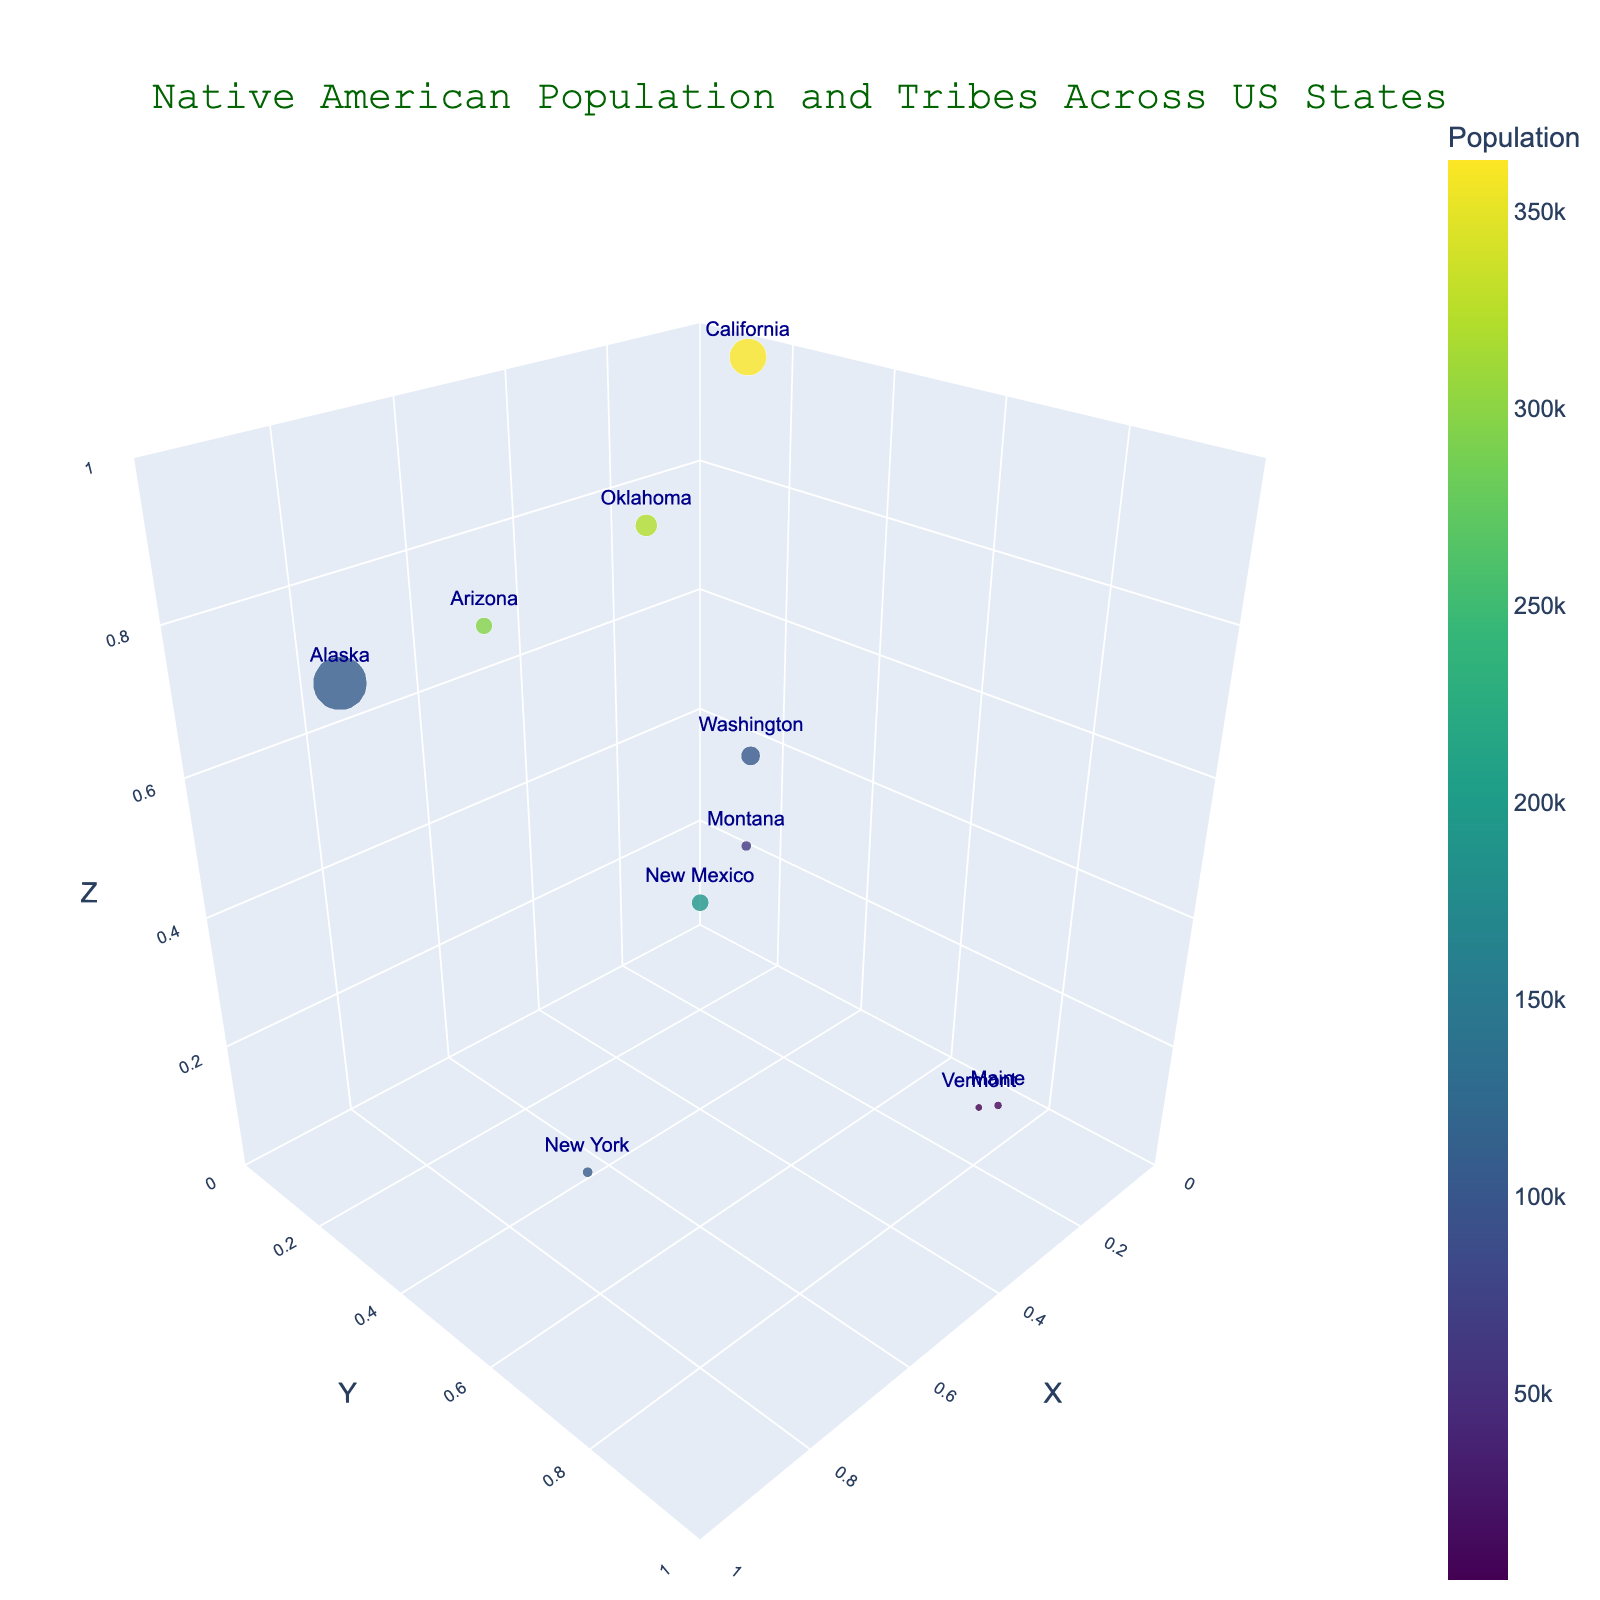What is the title of the figure? Look at the top of the figure where the title is usually placed. The title provided in the code is "Native American Population and Tribes Across US States".
Answer: Native American Population and Tribes Across US States Which state has the largest number of recognized tribes? Examine the size of the bubbles, as the size represents the number of recognized tribes. The largest bubble indicates the state with the most tribes, which the code tells us is Alaska with 229 tribes.
Answer: Alaska Which state has the smallest Native American population? Look at the color of the bubbles, as the color represents the population, with darker colored bubbles indicating smaller populations. The state with the smallest population is Vermont with 2,554 people.
Answer: Vermont How many states are represented in the figure? Count the number of bubbles in the figure, each representing a state. The data provided lists 10 states.
Answer: 10 What is the relationship between bubble size and number of recognized tribes? Observe that larger bubbles correspond to states with a higher number of recognized tribes. This is explicitly mentioned in the prompt, where bubble size indicates the number of recognized tribes.
Answer: Larger bubbles represent more tribes Which state has the highest Native American population but does not have the most recognized tribes? Compare the bubbles with the highest population color (brightest) but not the largest size. California has the highest population (362,801) but not the most tribes, which is 109 compared to Alaska's 229.
Answer: California What states have fewer than 10 recognized tribes and where are these bubbles located in terms of X, Y, Z axes? Identify the smaller bubbles in the plot, indicating fewer than 10 recognized tribes, and note their X, Y, Z coordinates. Vermont (0.2, 0.8, 0.1), New York (0.9, 0.7, 0.3), Maine (0.3, 0.9, 0.2), and Montana (0.3, 0.4, 0.4) qualify.
Answer: Vermont, New York, Maine, Montana Which state has a bubble roughly located at (0.8, 0.1, 0.7)? Look at the coordinates of the bubbles provided by X, Y, Z, and identify the state. The state around these coordinates is Alaska.
Answer: Alaska Compare the Native American population in Oklahoma and New Mexico and determine which state has a higher population. Referring to the bubble colors for these two states, check which has a brighter color indicating a higher population. Oklahoma has a brighter bubble, indicating 321,687 compared to New Mexico's 193,222.
Answer: Oklahoma How does the population color scale help differentiate states with similar numbers of recognized tribes? Look at the bubbles of similar sizes but different colors, and notice how the color scale (from darker to brighter) indicates differences in population, allowing differentiation. It helps distinguish states like Oklahoma and Arizona, which have similar tribe counts but different populations.
Answer: By showing population differences through color Which states are located near the center of the figure in terms of X, Y, Z axes? Look for bubbles around coordinates (0.5, 0.5, 0.5). Oklahoma (0.5, 0.4, 0.9) and New Mexico (0.6, 0.6, 0.5) are the closest to the center.
Answer: Oklahoma, New Mexico 